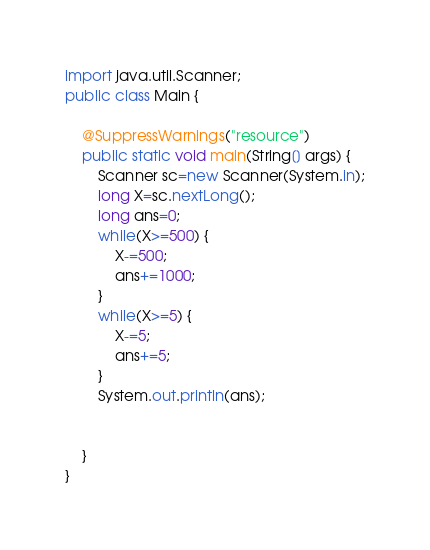Convert code to text. <code><loc_0><loc_0><loc_500><loc_500><_Java_>
import java.util.Scanner;
public class Main {

	@SuppressWarnings("resource")
	public static void main(String[] args) {
		Scanner sc=new Scanner(System.in);
		long X=sc.nextLong();
		long ans=0;
		while(X>=500) {
			X-=500;
			ans+=1000;
		}
		while(X>=5) {
			X-=5;
			ans+=5;
		}
		System.out.println(ans);


	}
}</code> 